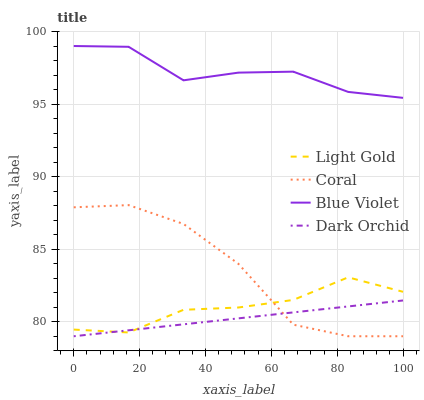Does Dark Orchid have the minimum area under the curve?
Answer yes or no. Yes. Does Blue Violet have the maximum area under the curve?
Answer yes or no. Yes. Does Light Gold have the minimum area under the curve?
Answer yes or no. No. Does Light Gold have the maximum area under the curve?
Answer yes or no. No. Is Dark Orchid the smoothest?
Answer yes or no. Yes. Is Coral the roughest?
Answer yes or no. Yes. Is Light Gold the smoothest?
Answer yes or no. No. Is Light Gold the roughest?
Answer yes or no. No. Does Light Gold have the lowest value?
Answer yes or no. No. Does Blue Violet have the highest value?
Answer yes or no. Yes. Does Light Gold have the highest value?
Answer yes or no. No. Is Coral less than Blue Violet?
Answer yes or no. Yes. Is Blue Violet greater than Light Gold?
Answer yes or no. Yes. Does Dark Orchid intersect Coral?
Answer yes or no. Yes. Is Dark Orchid less than Coral?
Answer yes or no. No. Is Dark Orchid greater than Coral?
Answer yes or no. No. Does Coral intersect Blue Violet?
Answer yes or no. No. 